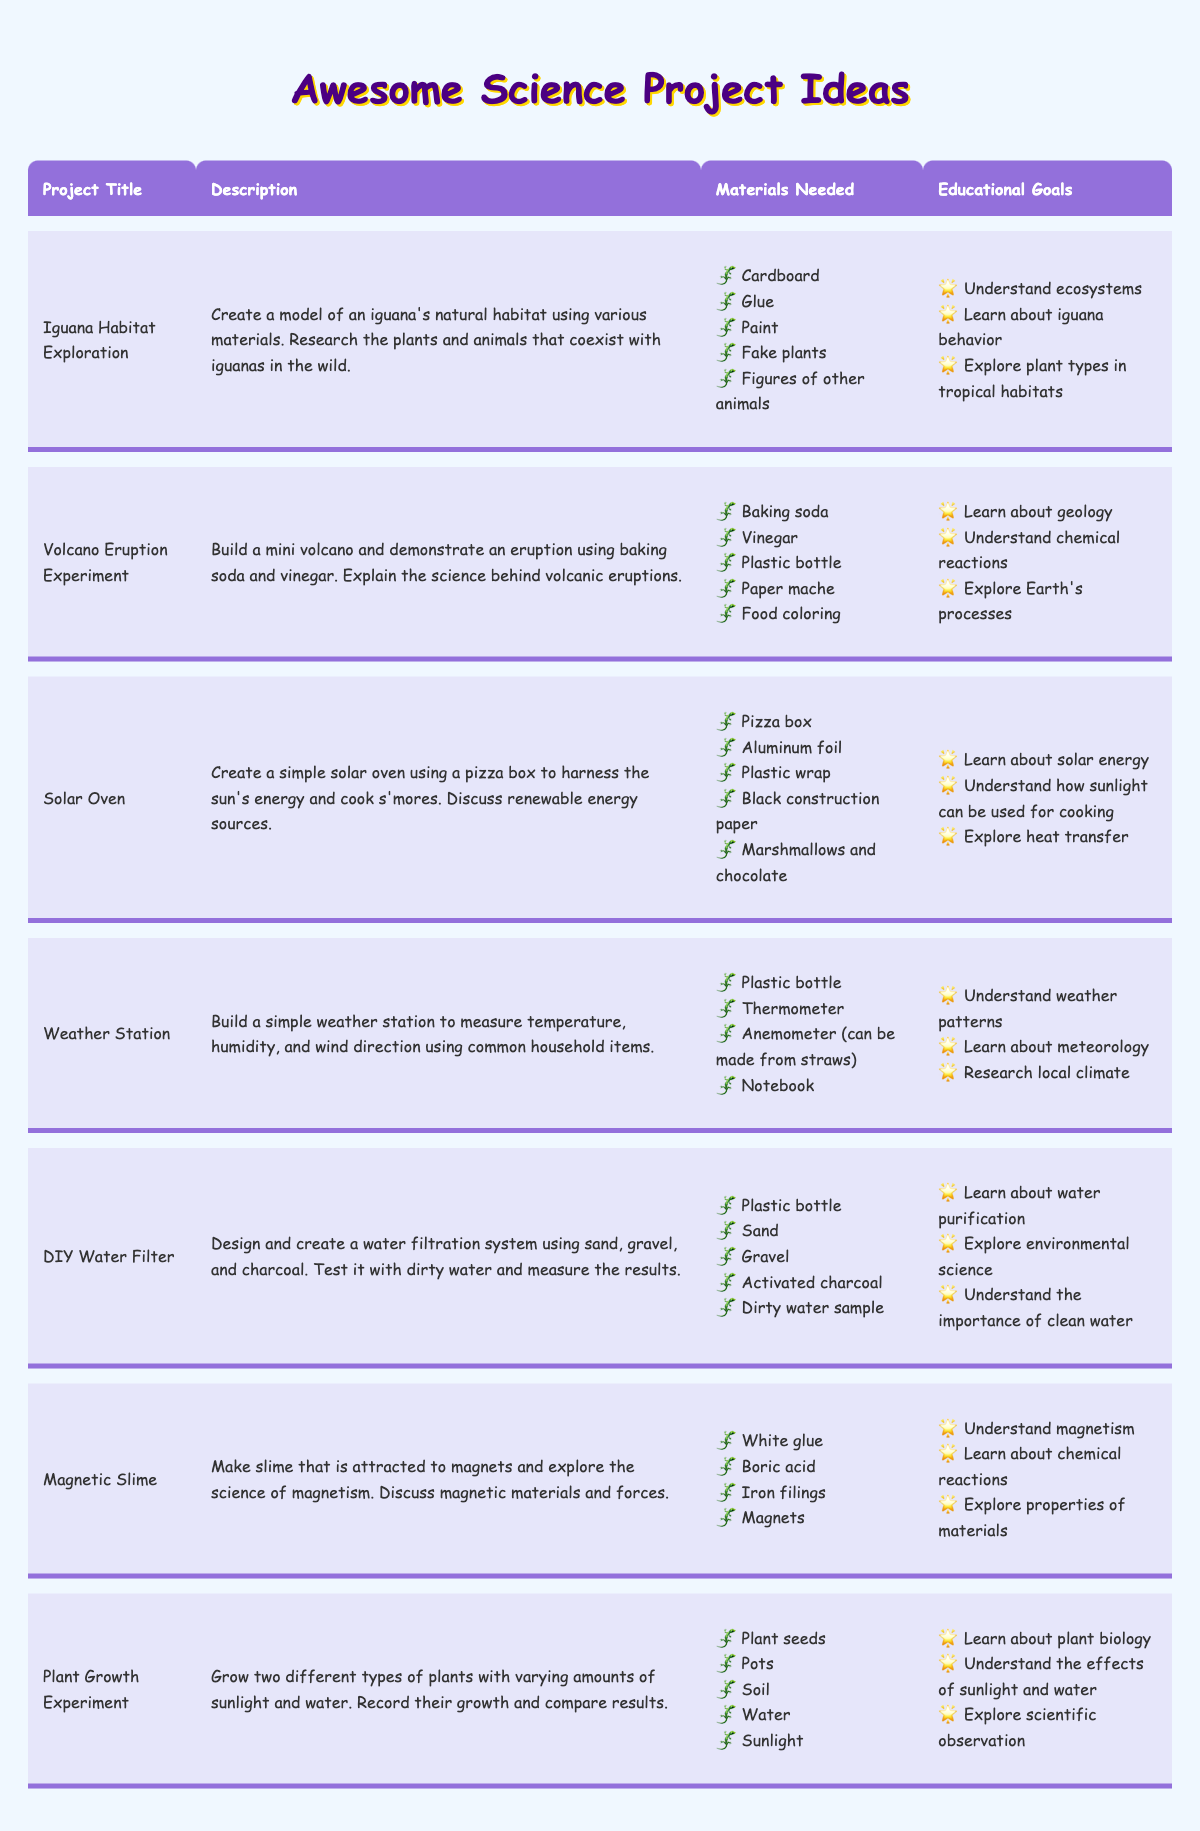What is the title of the project that involves iguanas? The title directly states "Iguana Habitat Exploration". This can be found in the "Project Title" column of the table.
Answer: Iguana Habitat Exploration Which project requires baking soda and vinegar? The project titled "Volcano Eruption Experiment" specifically lists baking soda and vinegar among its materials.
Answer: Volcano Eruption Experiment How many projects focus on renewable energy? The only project that focuses on renewable energy is the "Solar Oven", hence there is just one project here.
Answer: 1 Is the "Magnetic Slime" project aimed at understanding plant biology? No, the "Magnetic Slime" project focuses on understanding magnetism and chemical reactions, not plant biology. This information is found in the educational goals for that project.
Answer: No What materials are needed for the "DIY Water Filter" project? The materials listed under the DIY Water Filter project include "Plastic bottle", "Sand", "Gravel", "Activated charcoal", and "Dirty water sample". These are all specified in the materials needed column.
Answer: Plastic bottle, Sand, Gravel, Activated charcoal, Dirty water sample What are the educational goals for the "Weather Station" project? The educational goals for the "Weather Station" include understanding weather patterns, learning about meteorology, and researching local climate. This information can be directly found in the respective goals section of the project.
Answer: Understand weather patterns, Learn about meteorology, Research local climate How many different types of plants are grown in the "Plant Growth Experiment"? The "Plant Growth Experiment" specifies growing two different types of plants to compare their growth. Thus, the answer is two.
Answer: 2 Which project requires a notebook among its materials? The "Weather Station" project needs a notebook as one of its materials. This can be confirmed by looking at the materials needed list.
Answer: Weather Station What can you say about the "Solar Oven" project regarding cooking? The "Solar Oven" project demonstrates how to cook s'mores using a solar oven made from a pizza box, which harnesses the sun's energy. This involves a discussion about renewable energy sources.
Answer: It demonstrates cooking using solar energy 